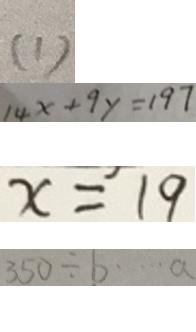Convert formula to latex. <formula><loc_0><loc_0><loc_500><loc_500>( 1 ) 
 1 4 x + 9 y = 1 9 7 
 x = 1 9 
 3 5 0 \div b \cdots a</formula> 